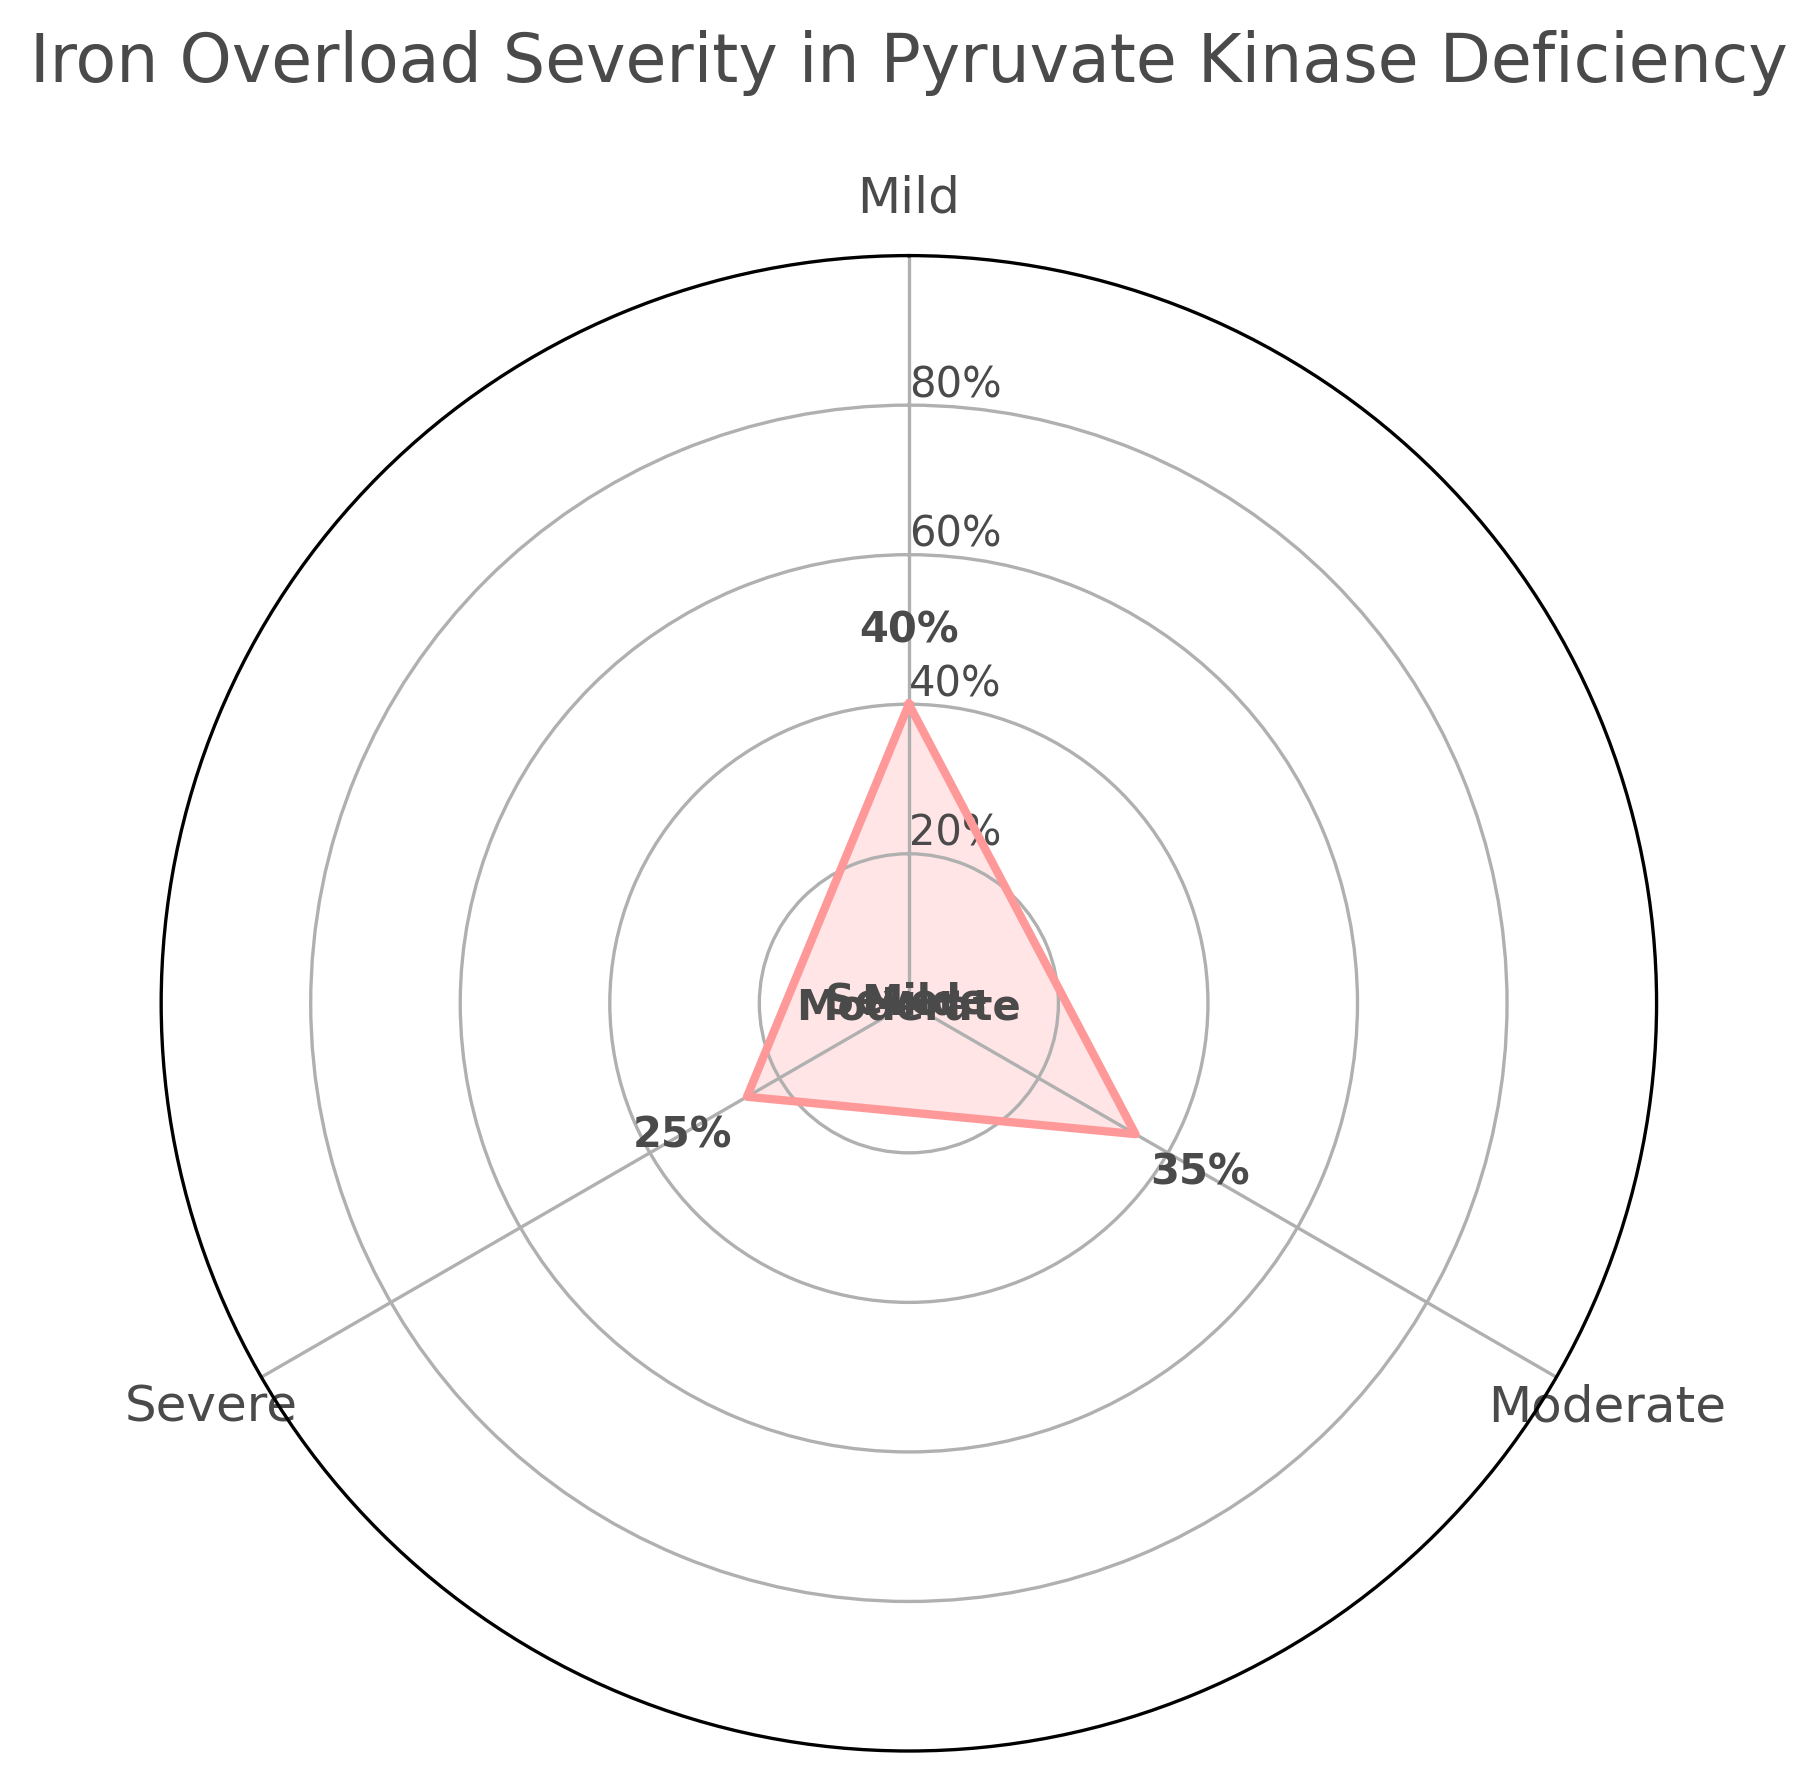What are the categories of iron overload severity shown in the figure? The figure lists three categories of iron overload severity, found around the circular gauge. They are labeled clearly in the image.
Answer: Mild, Moderate, Severe Which severity category has the highest percentage? By examining the figure, you can see that the largest segment corresponds to the 'Mild' category, which is more extended compared to the other segments.
Answer: Mild How much greater is the percentage of mild severity compared to severe severity? The percentage for mild severity is 40%, while it is 25% for severe severity. The difference can be calculated by subtracting 25 from 40.
Answer: 15% What is the title of the figure? The title is located at the top center of the figure and is labeled clearly.
Answer: Iron Overload Severity in Pyruvate Kinase Deficiency How many degree segments are used to represent each category in the gauge? The complete circle is 360 degrees, and there are three categories. Each segment is calculated by dividing 360 by 3.
Answer: 120 degrees What are the respective percentages of each severity category? The figure includes numeric labels next to each section. The percentages are 40% for Mild, 35% for Moderate, and 25% for Severe.
Answer: 40% (Mild), 35% (Moderate), 25% (Severe) What is the combined percentage of moderate and severe severity? Add up the percentages for Moderate (35%) and Severe (25%). This involves simple addition.
Answer: 60% Which severity category is represented by the smallest segment of the gauge chart? By observing the size of the segments, the smallest one corresponds to the Severe category.
Answer: Severe Is there a category with more than one-third of the total percentage? One-third of 100% is approximately 33.33%. The only category with a higher percentage is Mild, which is 40%.
Answer: Yes, Mild 